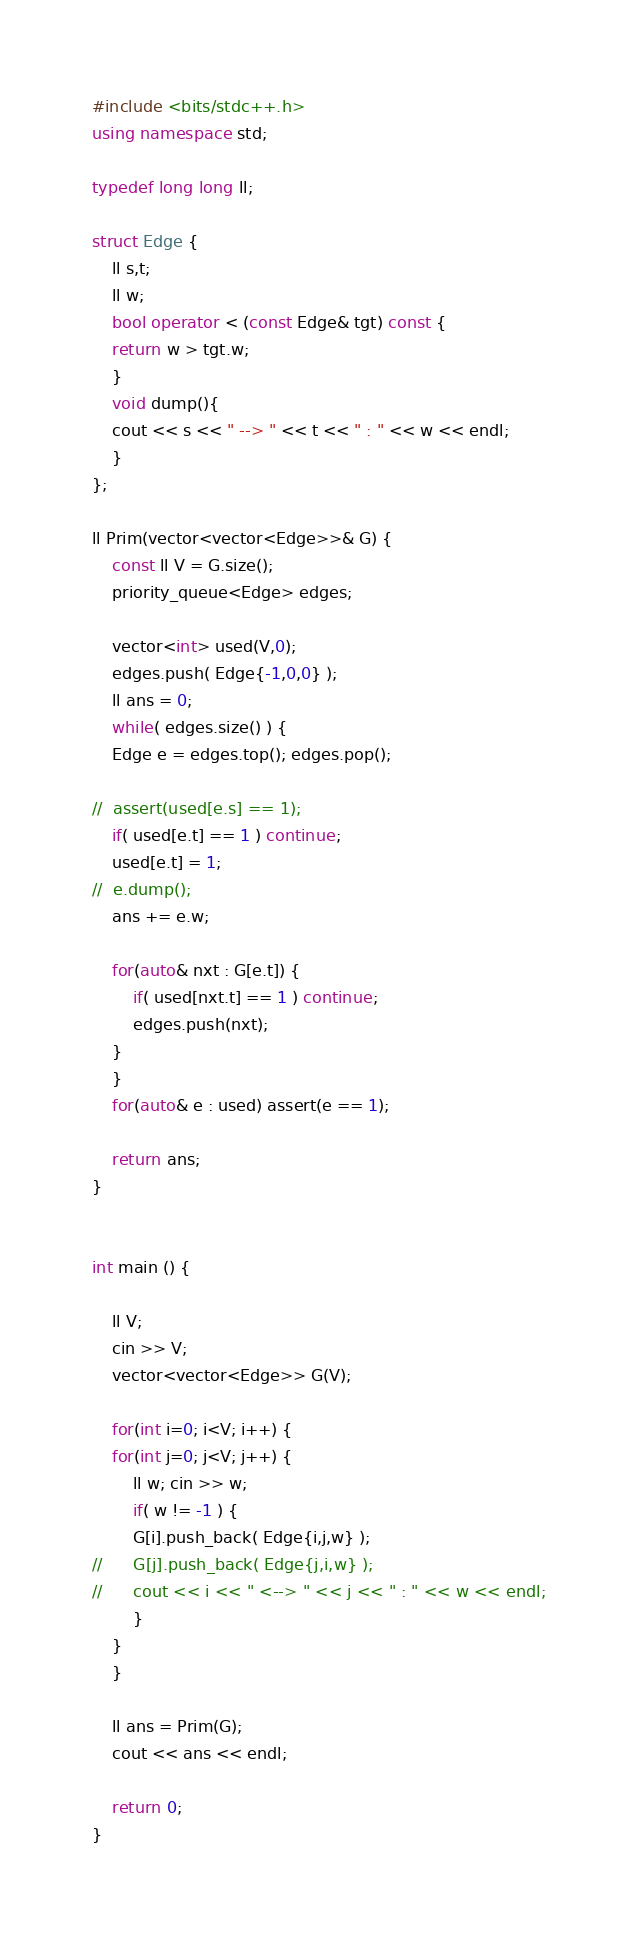<code> <loc_0><loc_0><loc_500><loc_500><_C++_>#include <bits/stdc++.h>
using namespace std;

typedef long long ll;

struct Edge {
    ll s,t;
    ll w;
    bool operator < (const Edge& tgt) const {
	return w > tgt.w;
    }
    void dump(){
	cout << s << " --> " << t << " : " << w << endl; 
    }
};

ll Prim(vector<vector<Edge>>& G) {
    const ll V = G.size();
    priority_queue<Edge> edges;
    
    vector<int> used(V,0);
    edges.push( Edge{-1,0,0} );
    ll ans = 0;
    while( edges.size() ) {
	Edge e = edges.top(); edges.pop();

//	assert(used[e.s] == 1);
	if( used[e.t] == 1 ) continue;
	used[e.t] = 1;
//	e.dump();
	ans += e.w;

	for(auto& nxt : G[e.t]) {
	    if( used[nxt.t] == 1 ) continue;
	    edges.push(nxt);
	}
    }
    for(auto& e : used) assert(e == 1);

    return ans;
}


int main () {

    ll V;
    cin >> V;
    vector<vector<Edge>> G(V);

    for(int i=0; i<V; i++) {
	for(int j=0; j<V; j++) {
	    ll w; cin >> w;
	    if( w != -1 ) {
		G[i].push_back( Edge{i,j,w} );
//		G[j].push_back( Edge{j,i,w} );
//		cout << i << " <--> " << j << " : " << w << endl; 
	    }
	}
    }

    ll ans = Prim(G);
    cout << ans << endl;
        
    return 0;
}</code> 